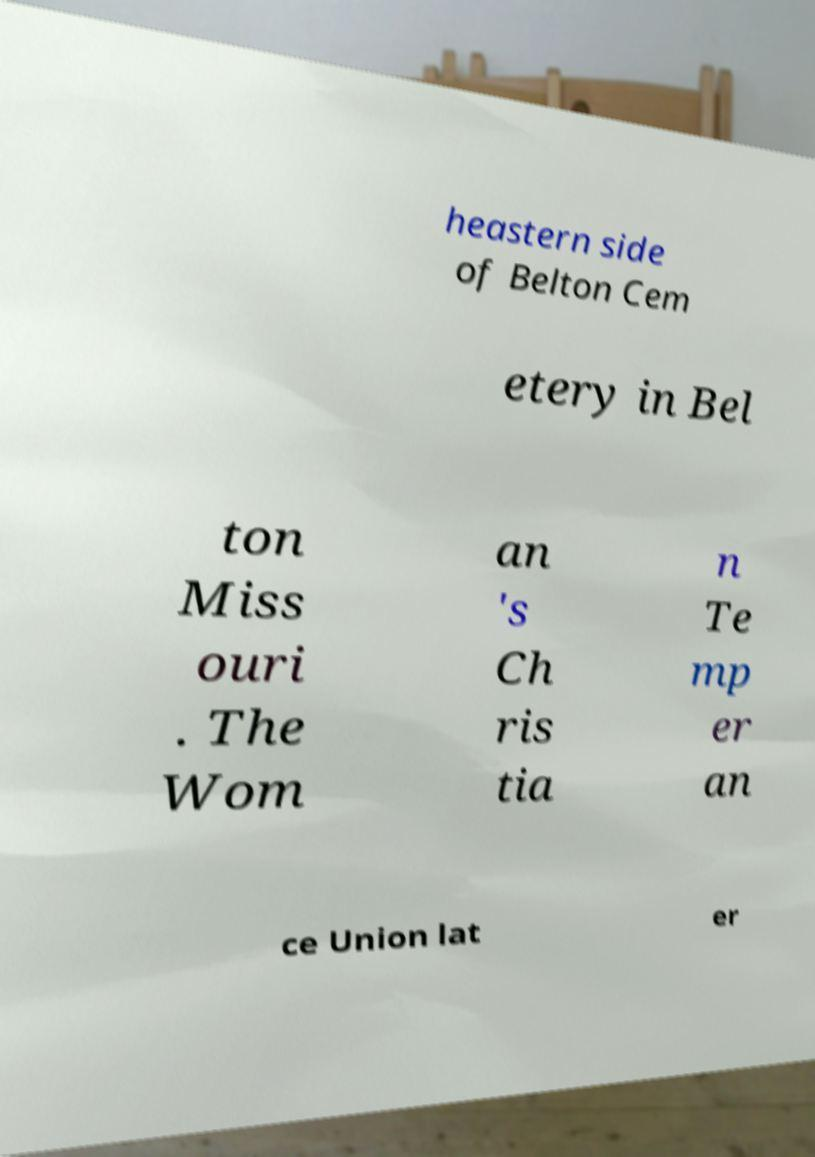There's text embedded in this image that I need extracted. Can you transcribe it verbatim? heastern side of Belton Cem etery in Bel ton Miss ouri . The Wom an 's Ch ris tia n Te mp er an ce Union lat er 